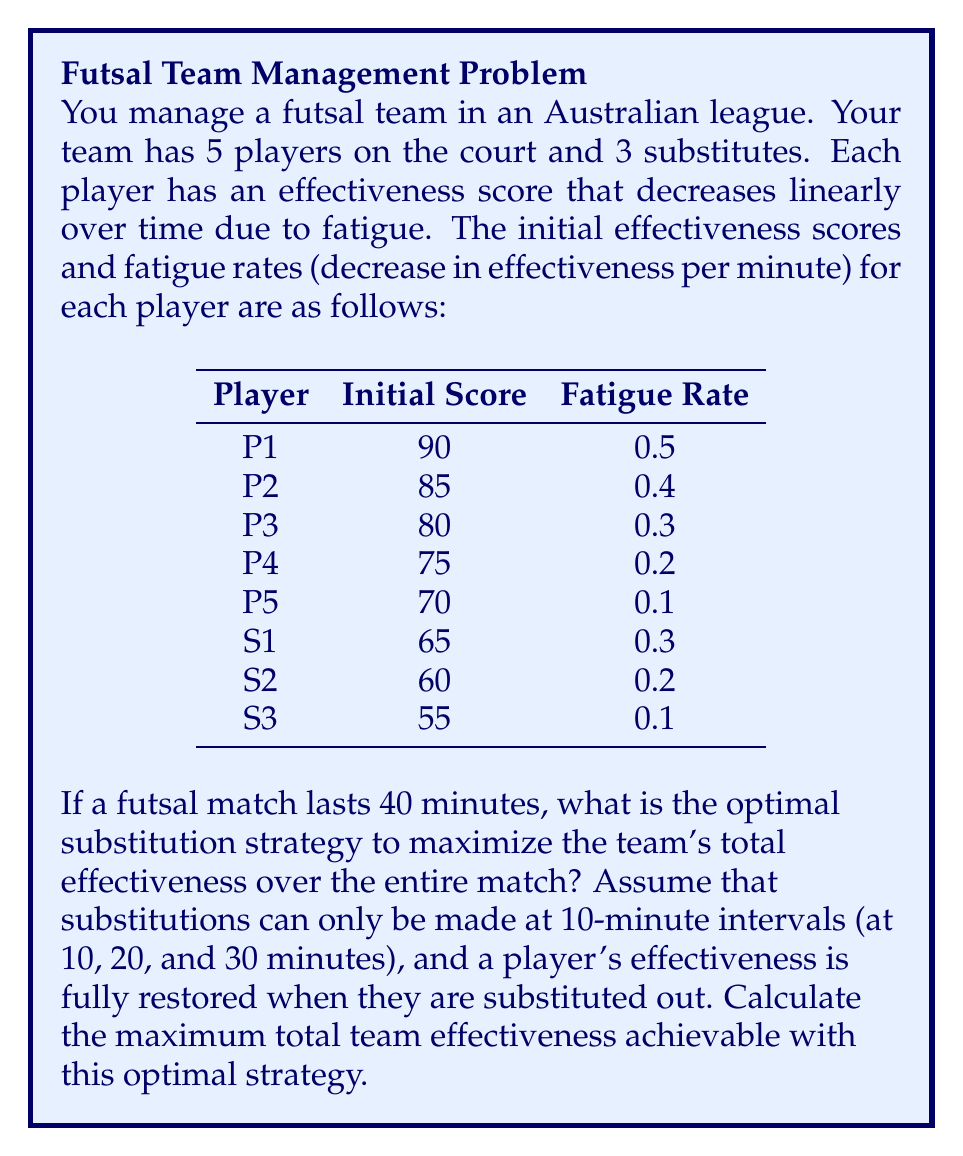Teach me how to tackle this problem. Let's approach this step-by-step:

1) First, we need to calculate each player's effectiveness at 10-minute intervals:

   For any player, Effectiveness at time t = Initial Score - (Fatigue Rate × t)

   At t = 10 minutes:
   P1: 90 - (0.5 × 10) = 85
   P2: 85 - (0.4 × 10) = 81
   P3: 80 - (0.3 × 10) = 77
   P4: 75 - (0.2 × 10) = 73
   P5: 70 - (0.1 × 10) = 69
   S1: 65 - (0.3 × 10) = 62
   S2: 60 - (0.2 × 10) = 58
   S3: 55 - (0.1 × 10) = 54

   We can calculate similar values for t = 20, 30, and 40 minutes.

2) To maximize total effectiveness, we should always have the 5 most effective players on the court.

3) At the start, the 5 most effective players are P1, P2, P3, P4, and P5.

4) At t = 10 minutes:
   The order of effectiveness is now P2 (81), P1 (85), P3 (77), P4 (73), P5 (69), S1 (65), S2 (60), S3 (55).
   No substitution is needed.

5) At t = 20 minutes:
   The order is P2 (77), P3 (74), P4 (71), P1 (70), S1 (65), P5 (68), S2 (60), S3 (55).
   We should substitute S1 for P5.

6) At t = 30 minutes:
   The order is P3 (71), P4 (69), S1 (62), P2 (73), S2 (60), P1 (65), S3 (55), P5 (70).
   We should substitute P5 for P1.

7) The total effectiveness is the sum of the top 5 players' scores in each 10-minute interval:

   0-10 minutes: 90 + 85 + 80 + 75 + 70 = 400
   10-20 minutes: 85 + 81 + 77 + 73 + 69 = 385
   20-30 minutes: 77 + 74 + 71 + 70 + 65 = 357
   30-40 minutes: 71 + 69 + 62 + 73 + 70 = 345

8) The maximum total team effectiveness is the sum of these:
   $$400 + 385 + 357 + 345 = 1487$$
Answer: 1487 